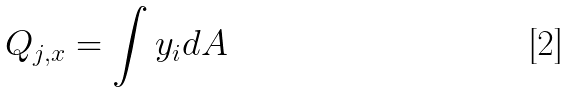Convert formula to latex. <formula><loc_0><loc_0><loc_500><loc_500>Q _ { j , x } = \int y _ { i } d A</formula> 